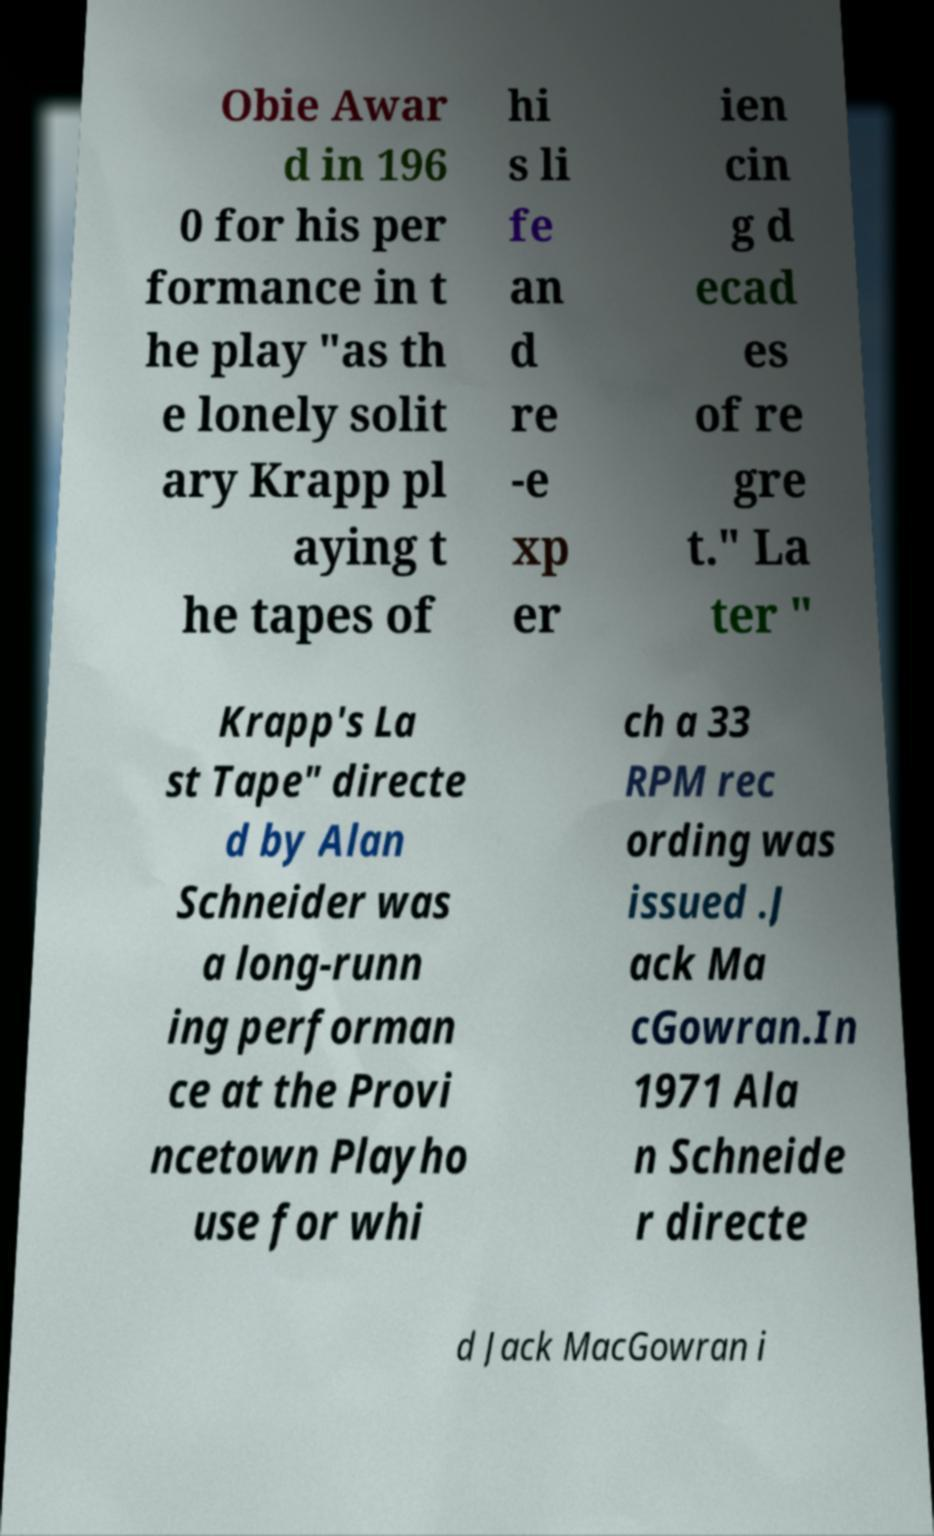Please identify and transcribe the text found in this image. Obie Awar d in 196 0 for his per formance in t he play "as th e lonely solit ary Krapp pl aying t he tapes of hi s li fe an d re -e xp er ien cin g d ecad es of re gre t." La ter " Krapp's La st Tape" directe d by Alan Schneider was a long-runn ing performan ce at the Provi ncetown Playho use for whi ch a 33 RPM rec ording was issued .J ack Ma cGowran.In 1971 Ala n Schneide r directe d Jack MacGowran i 